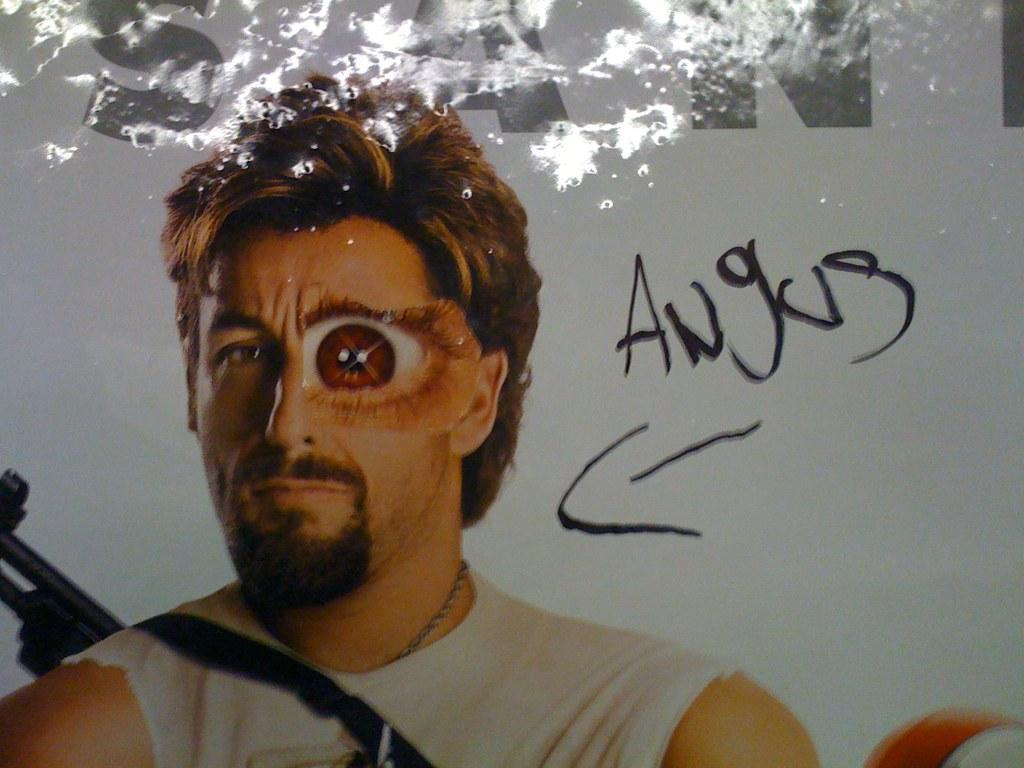Who is in the image? There is a man in the image. What is the man wearing? The man is wearing a gun. What else can be seen in the image besides the man? There is text present in the image. What type of cloth is being used to create the amusement in the image? There is no cloth or amusement present in the image; it features a man wearing a gun and text. 